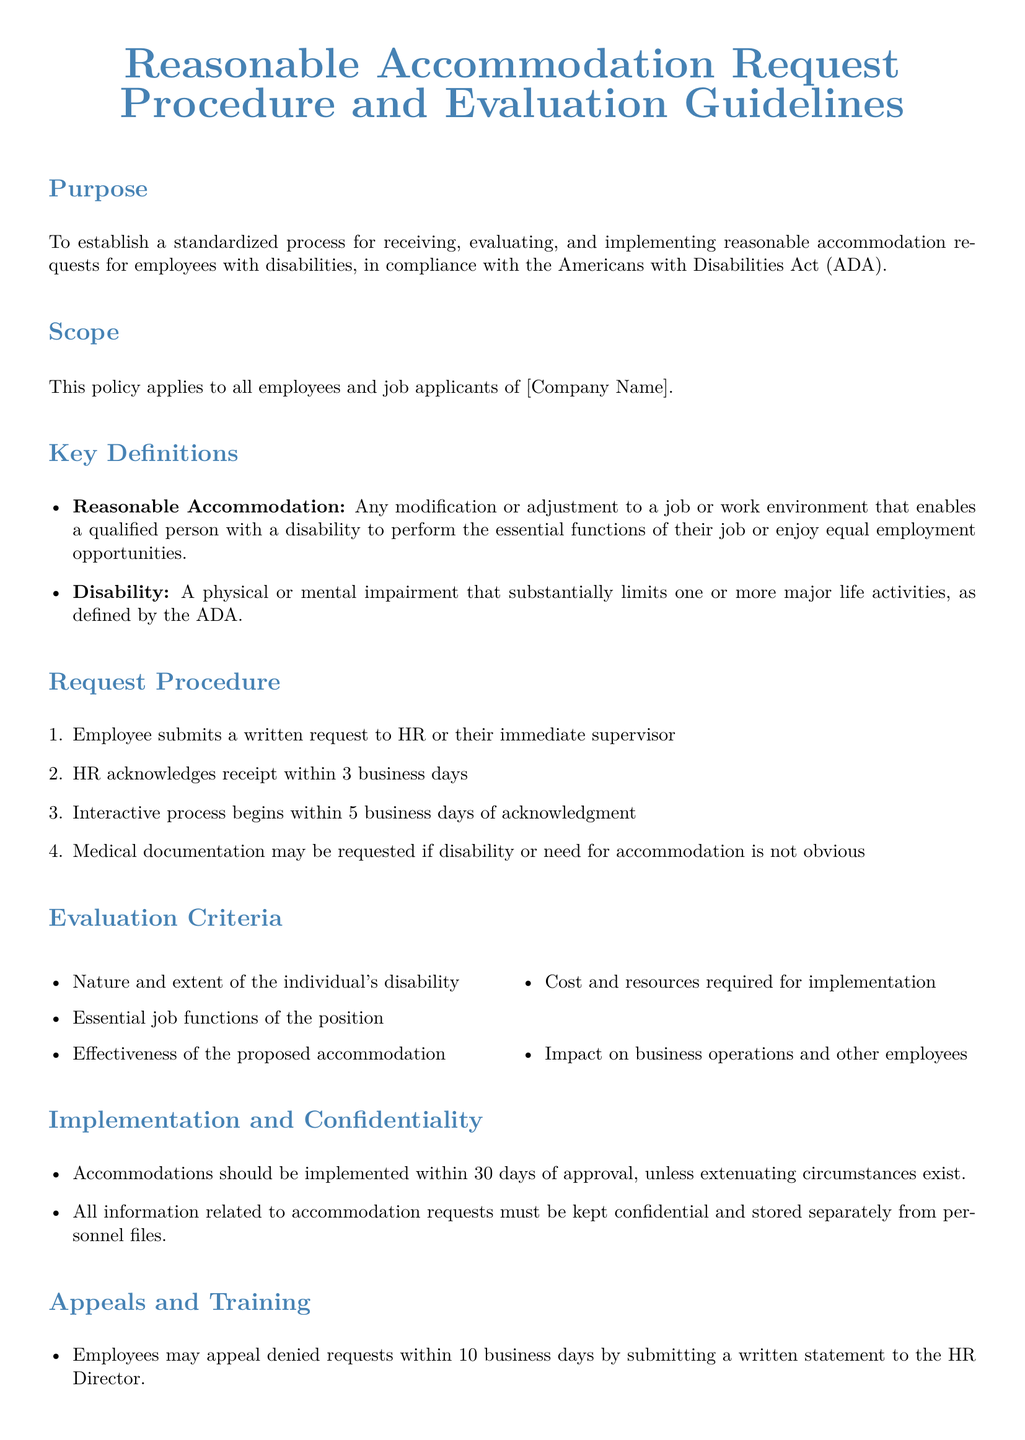what is the purpose of the document? The purpose is to establish a standardized process for receiving, evaluating, and implementing reasonable accommodation requests for employees with disabilities.
Answer: To establish a standardized process how many days does HR have to acknowledge receipt of a request? The document states that HR must acknowledge receipt within a specific timeframe.
Answer: 3 business days what is considered a reasonable accommodation? The document defines what constitutes a reasonable accommodation for employees.
Answer: Any modification or adjustment to a job or work environment what is the time frame for implementing accommodations after approval? The document specifies the timeframe for implementing accommodations.
Answer: 30 days who can appeal a denied request? The document notes who has the right to appeal a denied accommodation request.
Answer: Employees what is the first step in the request procedure? The document outlines the steps in the request procedure starting with the initial action required from employees.
Answer: Employee submits a written request what must be kept confidential according to the document? The document indicates what kind of information must be kept confidential.
Answer: All information related to accommodation requests how often will the policy be reviewed? The document states the frequency of policy review to ensure compliance and relevance.
Answer: Annually 